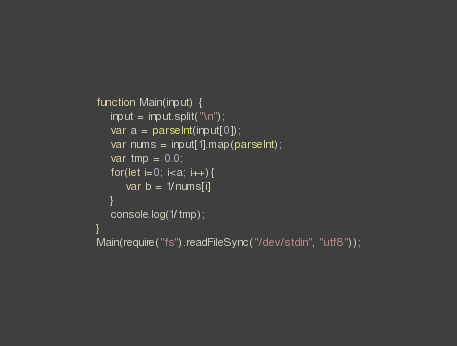Convert code to text. <code><loc_0><loc_0><loc_500><loc_500><_JavaScript_>function Main(input) {
    input = input.split("\n");
    var a = parseInt(input[0]);
    var nums = input[1].map(parseInt);
    var tmp = 0.0;
    for(let i=0; i<a; i++){
        var b = 1/nums[i]
    }
    console.log(1/tmp);
}
Main(require("fs").readFileSync("/dev/stdin", "utf8"));
</code> 